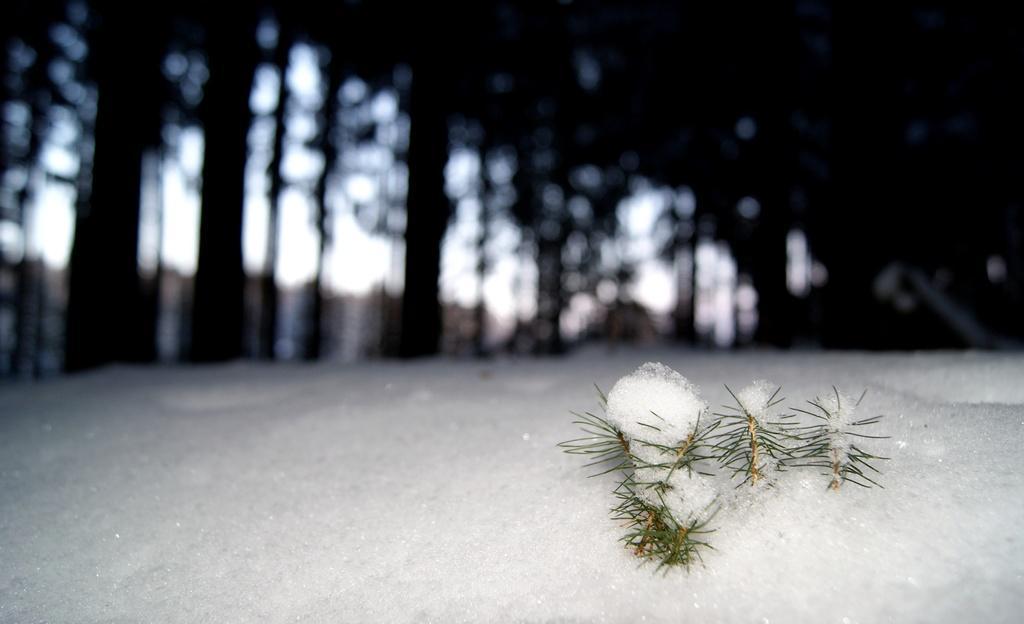In one or two sentences, can you explain what this image depicts? Front of the image we can see snow and grass. Background it is blurry and we can see able to see trees. 